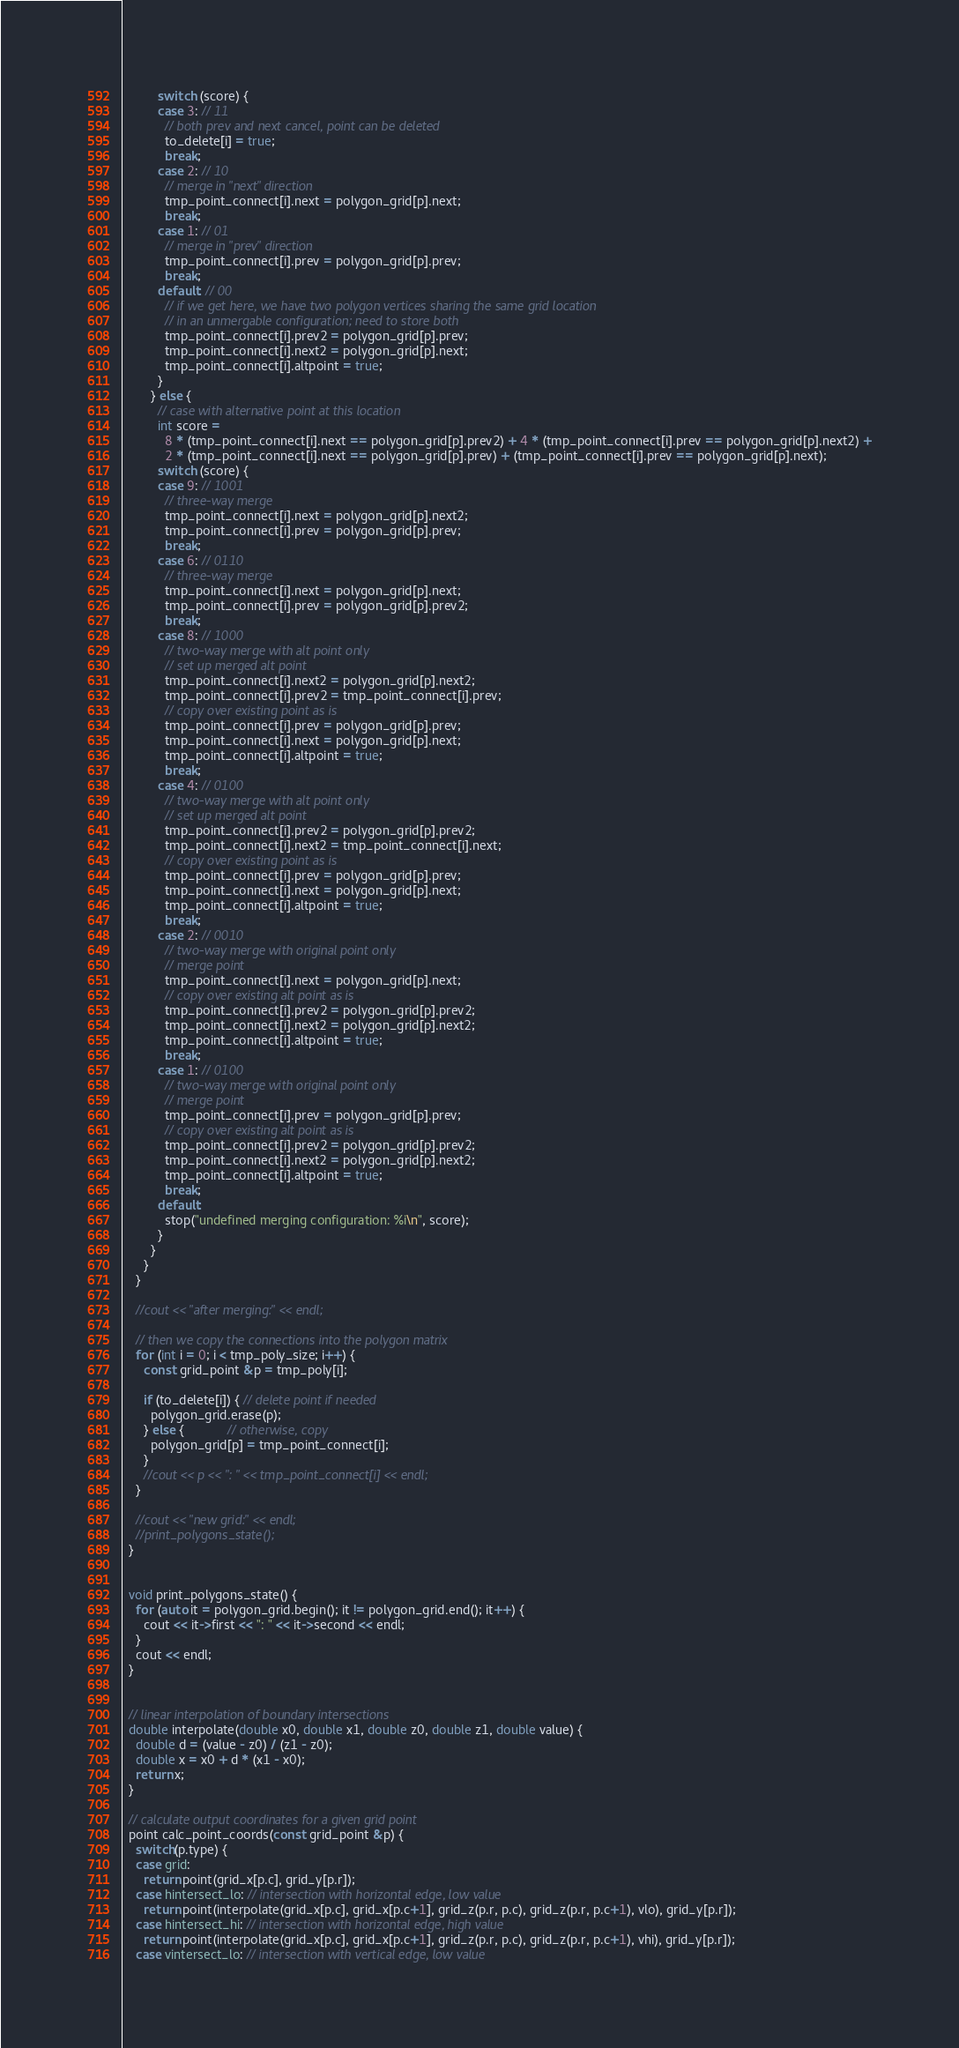Convert code to text. <code><loc_0><loc_0><loc_500><loc_500><_C++_>          switch (score) {
          case 3: // 11
            // both prev and next cancel, point can be deleted
            to_delete[i] = true;
            break;
          case 2: // 10
            // merge in "next" direction
            tmp_point_connect[i].next = polygon_grid[p].next;
            break;
          case 1: // 01
            // merge in "prev" direction
            tmp_point_connect[i].prev = polygon_grid[p].prev;
            break;
          default: // 00
            // if we get here, we have two polygon vertices sharing the same grid location
            // in an unmergable configuration; need to store both
            tmp_point_connect[i].prev2 = polygon_grid[p].prev;
            tmp_point_connect[i].next2 = polygon_grid[p].next;
            tmp_point_connect[i].altpoint = true;
          }
        } else {
          // case with alternative point at this location
          int score =
            8 * (tmp_point_connect[i].next == polygon_grid[p].prev2) + 4 * (tmp_point_connect[i].prev == polygon_grid[p].next2) +
            2 * (tmp_point_connect[i].next == polygon_grid[p].prev) + (tmp_point_connect[i].prev == polygon_grid[p].next);
          switch (score) {
          case 9: // 1001
            // three-way merge
            tmp_point_connect[i].next = polygon_grid[p].next2;
            tmp_point_connect[i].prev = polygon_grid[p].prev;
            break;
          case 6: // 0110
            // three-way merge
            tmp_point_connect[i].next = polygon_grid[p].next;
            tmp_point_connect[i].prev = polygon_grid[p].prev2;
            break;
          case 8: // 1000
            // two-way merge with alt point only
            // set up merged alt point
            tmp_point_connect[i].next2 = polygon_grid[p].next2;
            tmp_point_connect[i].prev2 = tmp_point_connect[i].prev;
            // copy over existing point as is
            tmp_point_connect[i].prev = polygon_grid[p].prev;
            tmp_point_connect[i].next = polygon_grid[p].next;
            tmp_point_connect[i].altpoint = true;
            break;
          case 4: // 0100
            // two-way merge with alt point only
            // set up merged alt point
            tmp_point_connect[i].prev2 = polygon_grid[p].prev2;
            tmp_point_connect[i].next2 = tmp_point_connect[i].next;
            // copy over existing point as is
            tmp_point_connect[i].prev = polygon_grid[p].prev;
            tmp_point_connect[i].next = polygon_grid[p].next;
            tmp_point_connect[i].altpoint = true;
            break;
          case 2: // 0010
            // two-way merge with original point only
            // merge point
            tmp_point_connect[i].next = polygon_grid[p].next;
            // copy over existing alt point as is
            tmp_point_connect[i].prev2 = polygon_grid[p].prev2;
            tmp_point_connect[i].next2 = polygon_grid[p].next2;
            tmp_point_connect[i].altpoint = true;
            break;
          case 1: // 0100
            // two-way merge with original point only
            // merge point
            tmp_point_connect[i].prev = polygon_grid[p].prev;
            // copy over existing alt point as is
            tmp_point_connect[i].prev2 = polygon_grid[p].prev2;
            tmp_point_connect[i].next2 = polygon_grid[p].next2;
            tmp_point_connect[i].altpoint = true;
            break;
          default:
            stop("undefined merging configuration: %i\n", score);
          }
        }
      }
    }

    //cout << "after merging:" << endl;

    // then we copy the connections into the polygon matrix
    for (int i = 0; i < tmp_poly_size; i++) {
      const grid_point &p = tmp_poly[i];

      if (to_delete[i]) { // delete point if needed
        polygon_grid.erase(p);
      } else {            // otherwise, copy
        polygon_grid[p] = tmp_point_connect[i];
      }
      //cout << p << ": " << tmp_point_connect[i] << endl;
    }

    //cout << "new grid:" << endl;
    //print_polygons_state();
  }


  void print_polygons_state() {
    for (auto it = polygon_grid.begin(); it != polygon_grid.end(); it++) {
      cout << it->first << ": " << it->second << endl;
    }
    cout << endl;
  }


  // linear interpolation of boundary intersections
  double interpolate(double x0, double x1, double z0, double z1, double value) {
    double d = (value - z0) / (z1 - z0);
    double x = x0 + d * (x1 - x0);
    return x;
  }

  // calculate output coordinates for a given grid point
  point calc_point_coords(const grid_point &p) {
    switch(p.type) {
    case grid:
      return point(grid_x[p.c], grid_y[p.r]);
    case hintersect_lo: // intersection with horizontal edge, low value
      return point(interpolate(grid_x[p.c], grid_x[p.c+1], grid_z(p.r, p.c), grid_z(p.r, p.c+1), vlo), grid_y[p.r]);
    case hintersect_hi: // intersection with horizontal edge, high value
      return point(interpolate(grid_x[p.c], grid_x[p.c+1], grid_z(p.r, p.c), grid_z(p.r, p.c+1), vhi), grid_y[p.r]);
    case vintersect_lo: // intersection with vertical edge, low value</code> 